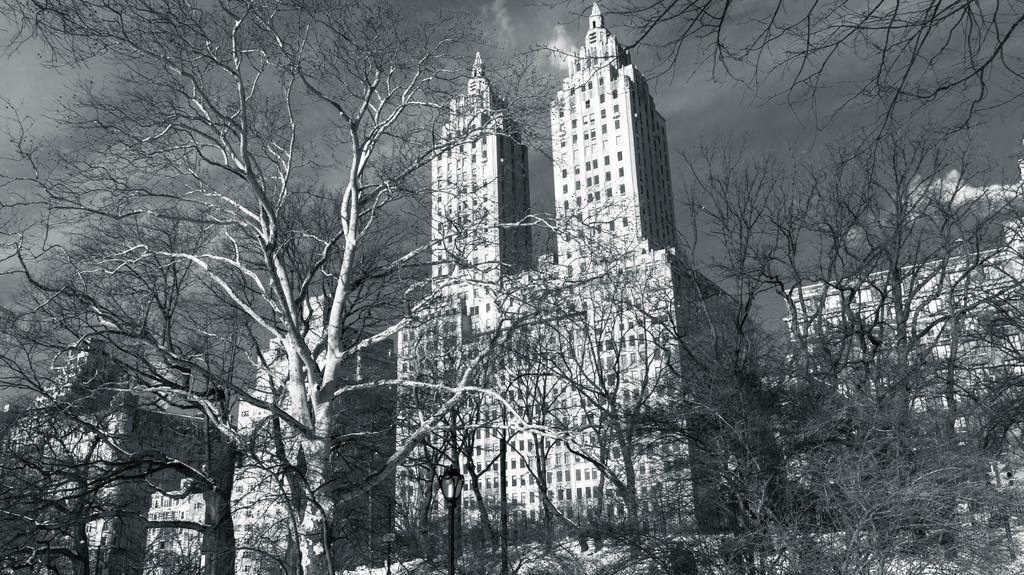How would you summarize this image in a sentence or two? This image is a black and white image. This image is taken outdoors. At the top of the image there is the sky with clouds. In the background there are a few buildings with walls, windows, doors and roofs. In the middle of the image there are many trees with stems and branches. 